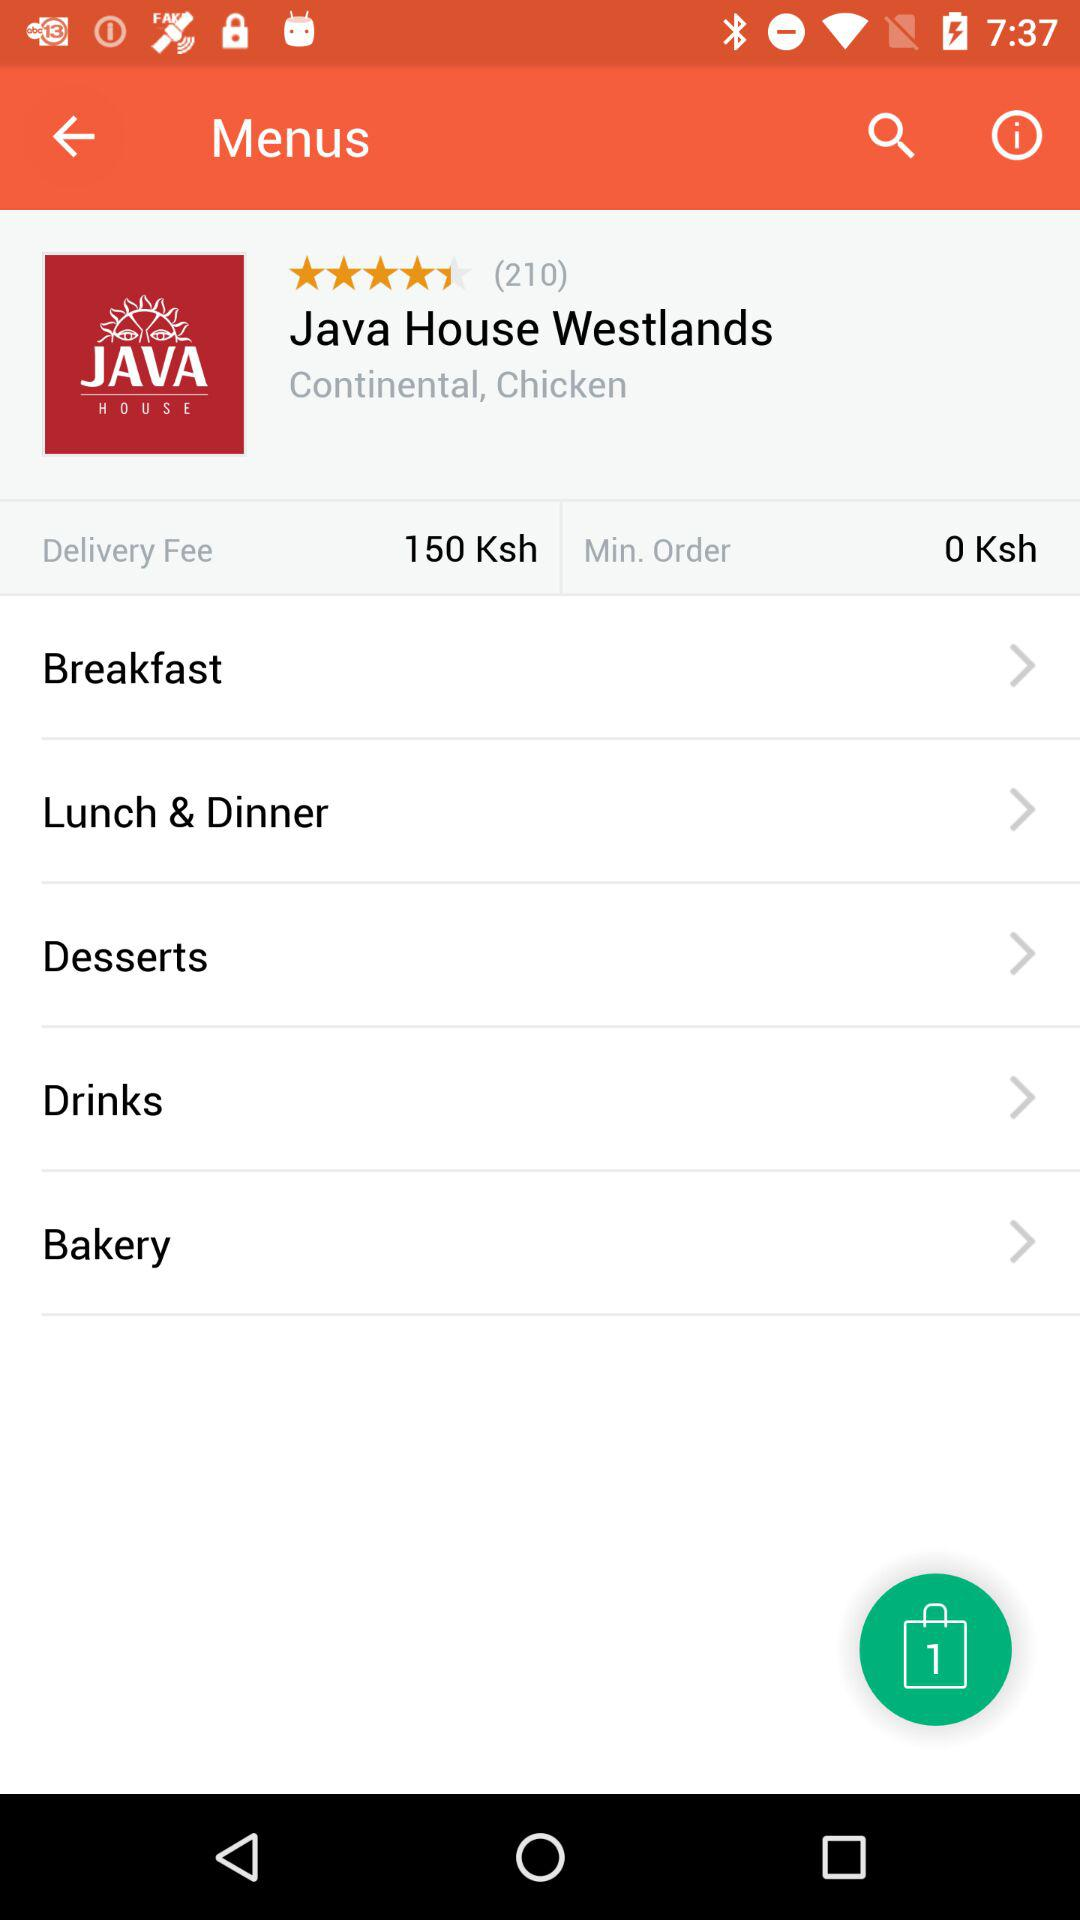What is the rating of Java House Westland? The rating is 4 stars. 